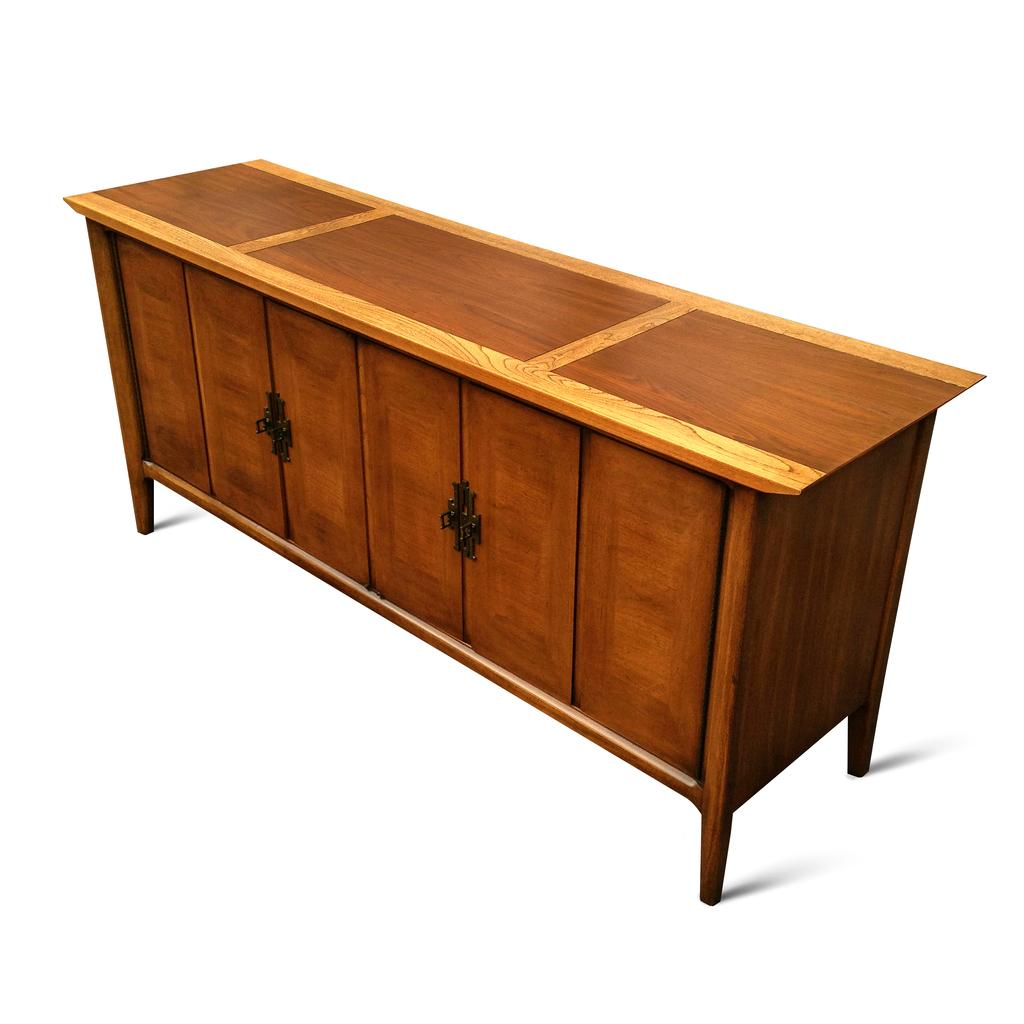What type of furniture is present in the image? There is a table in the image. What color is the table? The table is brown in color. What type of cemetery can be seen in the background of the image? There is no cemetery present in the image; it only features a brown table. 